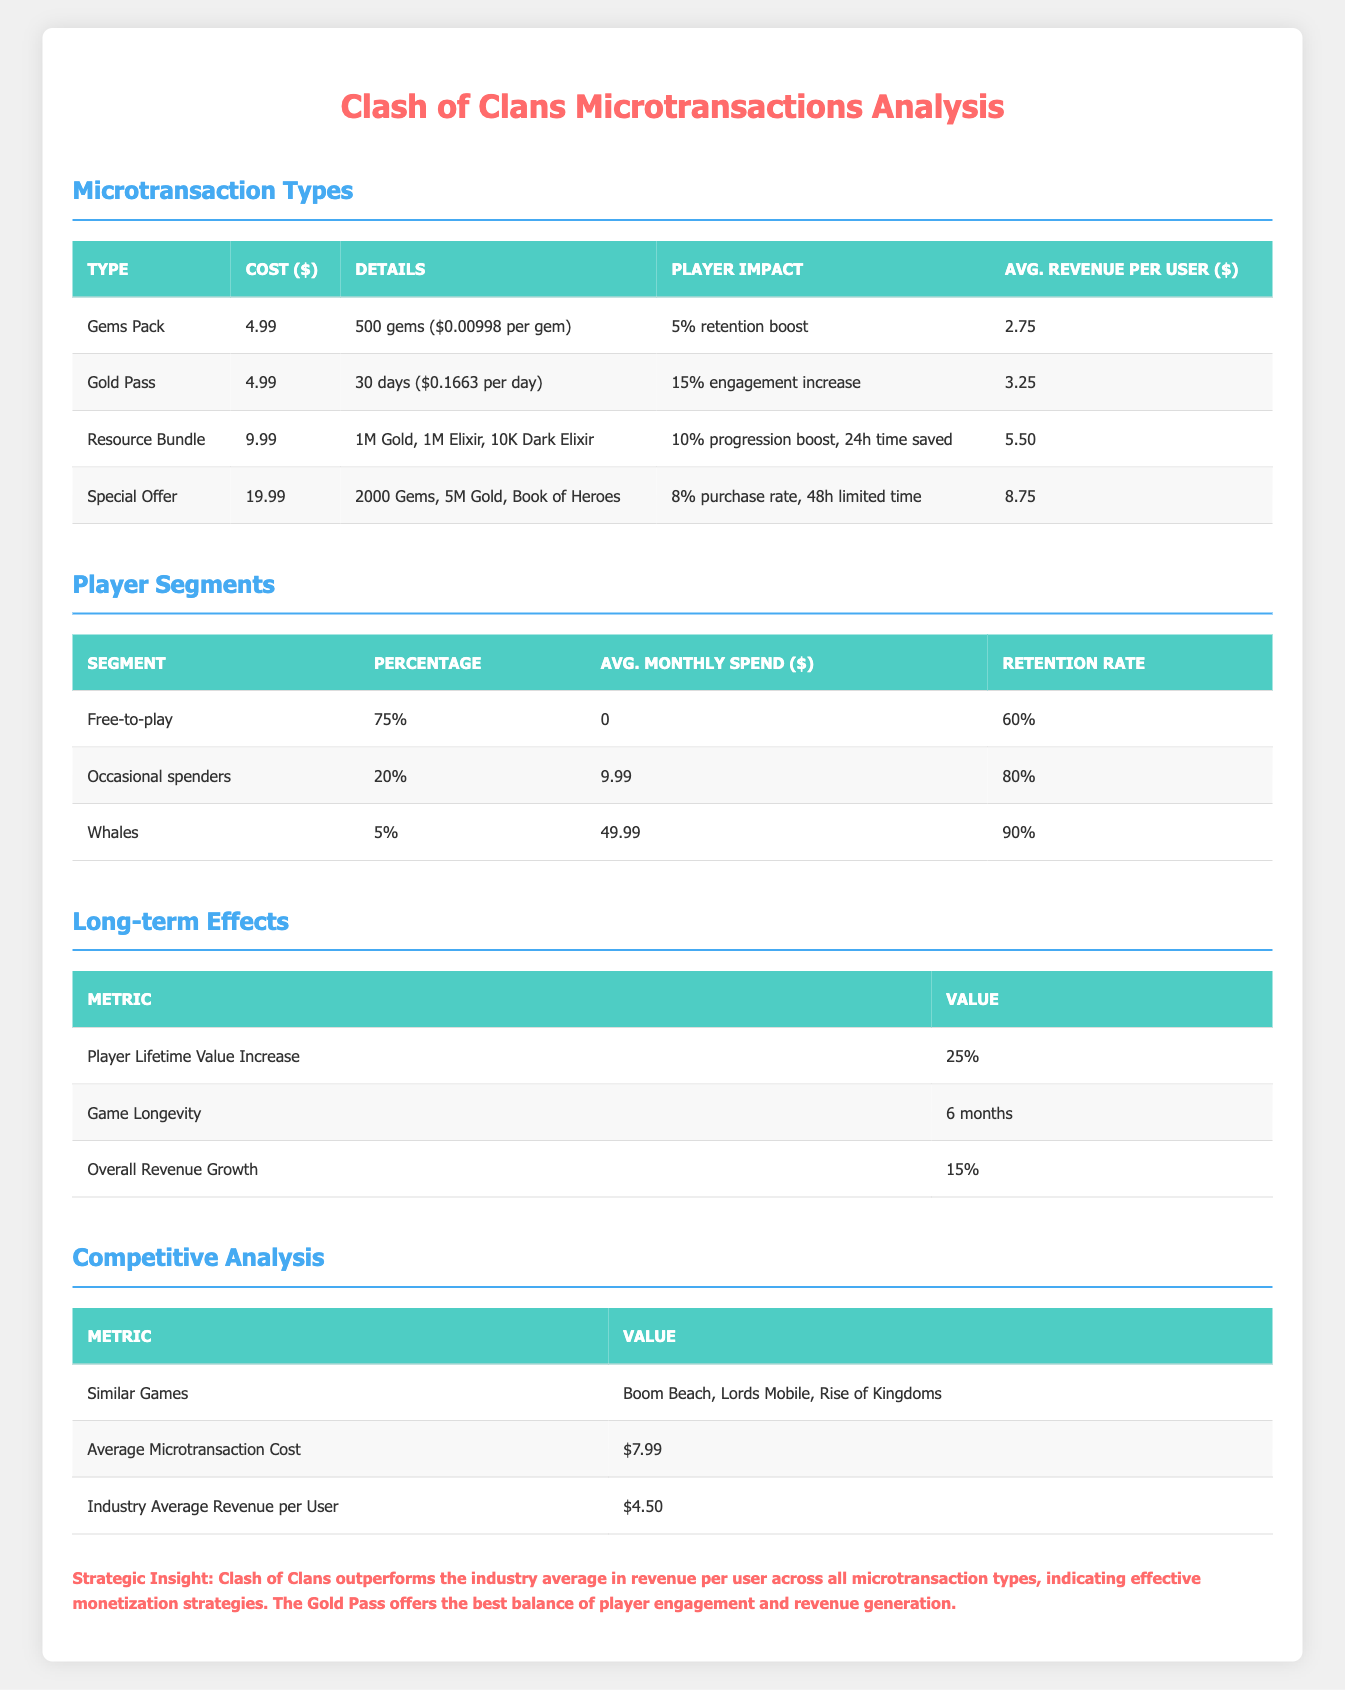What is the cost of the Gold Pass microtransaction? The Gold Pass is listed in the table with a specified cost, which is clearly indicated as 4.99 dollars.
Answer: 4.99 What is the average revenue per user for the Special Offer? In the table, the average revenue per user for the Special Offer is provided as 8.75 dollars.
Answer: 8.75 What percentage of players are classified as Free-to-play? The table shows that 75% of players fall into the Free-to-play category.
Answer: 75% True or false: The average monthly spend of whales is greater than the average monthly spend of occasional spenders. The table indicates that whales spend 49.99 dollars monthly while occasional spenders spend 9.99 dollars per month, confirming that whales have a higher average spend.
Answer: True What is the total average monthly spend of all player segments? To find the total, we multiply each segment's percentage by their average monthly spend: (0.75 * 0) + (0.2 * 9.99) + (0.05 * 49.99) = 0 + 1.998 + 2.4995 = 4.4975 dollars.
Answer: 4.50 Which microtransaction type has the highest average revenue per user? By comparing the average revenue per user across all microtransaction types in the table, the "Special Offer" has the highest at 8.75 dollars.
Answer: Special Offer How much time can be saved by purchasing the Resource Bundle? The Resource Bundle clearly states that it provides a time savings of 24 hours in the table.
Answer: 24 hours What is the player retention rate for occasional spenders? The table shows that the retention rate for occasional spenders is 80%.
Answer: 80% What is the difference between the average revenue per user of the Gold Pass and the Resource Bundle? To find the difference, subtract the average revenue per user of the Gold Pass, which is 3.25, from that of the Resource Bundle, which is 5.50: 5.50 - 3.25 = 2.25 dollars.
Answer: 2.25 What is the average microtransaction cost compared to the cost of the Gems Pack? The average microtransaction cost in the competitive analysis is 7.99 dollars, while the Gems Pack costs 4.99 dollars. Since 4.99 is less than 7.99, it shows that the Gems Pack is cheaper.
Answer: Gems Pack is cheaper 